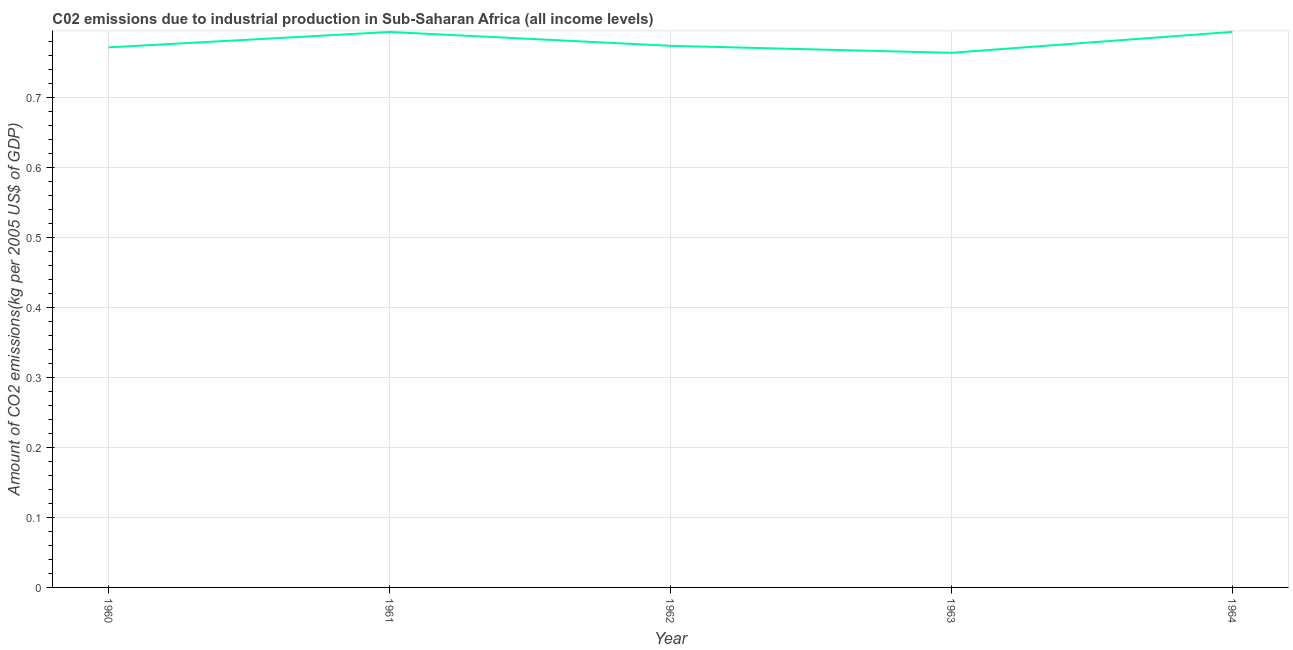What is the amount of co2 emissions in 1961?
Your response must be concise. 0.79. Across all years, what is the maximum amount of co2 emissions?
Keep it short and to the point. 0.79. Across all years, what is the minimum amount of co2 emissions?
Offer a very short reply. 0.76. In which year was the amount of co2 emissions maximum?
Provide a short and direct response. 1964. In which year was the amount of co2 emissions minimum?
Offer a very short reply. 1963. What is the sum of the amount of co2 emissions?
Give a very brief answer. 3.89. What is the difference between the amount of co2 emissions in 1962 and 1963?
Make the answer very short. 0.01. What is the average amount of co2 emissions per year?
Offer a terse response. 0.78. What is the median amount of co2 emissions?
Offer a very short reply. 0.77. In how many years, is the amount of co2 emissions greater than 0.48000000000000004 kg per 2005 US$ of GDP?
Your answer should be compact. 5. Do a majority of the years between 1964 and 1963 (inclusive) have amount of co2 emissions greater than 0.42000000000000004 kg per 2005 US$ of GDP?
Provide a short and direct response. No. What is the ratio of the amount of co2 emissions in 1962 to that in 1963?
Make the answer very short. 1.01. Is the amount of co2 emissions in 1960 less than that in 1961?
Offer a terse response. Yes. Is the difference between the amount of co2 emissions in 1960 and 1964 greater than the difference between any two years?
Offer a terse response. No. What is the difference between the highest and the second highest amount of co2 emissions?
Make the answer very short. 0. Is the sum of the amount of co2 emissions in 1960 and 1963 greater than the maximum amount of co2 emissions across all years?
Your answer should be compact. Yes. What is the difference between the highest and the lowest amount of co2 emissions?
Your answer should be compact. 0.03. How many years are there in the graph?
Provide a short and direct response. 5. Does the graph contain grids?
Ensure brevity in your answer.  Yes. What is the title of the graph?
Make the answer very short. C02 emissions due to industrial production in Sub-Saharan Africa (all income levels). What is the label or title of the X-axis?
Offer a terse response. Year. What is the label or title of the Y-axis?
Offer a very short reply. Amount of CO2 emissions(kg per 2005 US$ of GDP). What is the Amount of CO2 emissions(kg per 2005 US$ of GDP) of 1960?
Make the answer very short. 0.77. What is the Amount of CO2 emissions(kg per 2005 US$ of GDP) of 1961?
Offer a terse response. 0.79. What is the Amount of CO2 emissions(kg per 2005 US$ of GDP) in 1962?
Offer a terse response. 0.77. What is the Amount of CO2 emissions(kg per 2005 US$ of GDP) in 1963?
Ensure brevity in your answer.  0.76. What is the Amount of CO2 emissions(kg per 2005 US$ of GDP) of 1964?
Your answer should be compact. 0.79. What is the difference between the Amount of CO2 emissions(kg per 2005 US$ of GDP) in 1960 and 1961?
Provide a short and direct response. -0.02. What is the difference between the Amount of CO2 emissions(kg per 2005 US$ of GDP) in 1960 and 1962?
Keep it short and to the point. -0. What is the difference between the Amount of CO2 emissions(kg per 2005 US$ of GDP) in 1960 and 1963?
Ensure brevity in your answer.  0.01. What is the difference between the Amount of CO2 emissions(kg per 2005 US$ of GDP) in 1960 and 1964?
Offer a terse response. -0.02. What is the difference between the Amount of CO2 emissions(kg per 2005 US$ of GDP) in 1961 and 1962?
Make the answer very short. 0.02. What is the difference between the Amount of CO2 emissions(kg per 2005 US$ of GDP) in 1961 and 1963?
Your response must be concise. 0.03. What is the difference between the Amount of CO2 emissions(kg per 2005 US$ of GDP) in 1961 and 1964?
Provide a short and direct response. -0. What is the difference between the Amount of CO2 emissions(kg per 2005 US$ of GDP) in 1962 and 1964?
Offer a terse response. -0.02. What is the difference between the Amount of CO2 emissions(kg per 2005 US$ of GDP) in 1963 and 1964?
Your answer should be compact. -0.03. What is the ratio of the Amount of CO2 emissions(kg per 2005 US$ of GDP) in 1961 to that in 1963?
Your answer should be compact. 1.04. What is the ratio of the Amount of CO2 emissions(kg per 2005 US$ of GDP) in 1962 to that in 1964?
Your answer should be compact. 0.97. What is the ratio of the Amount of CO2 emissions(kg per 2005 US$ of GDP) in 1963 to that in 1964?
Your answer should be very brief. 0.96. 